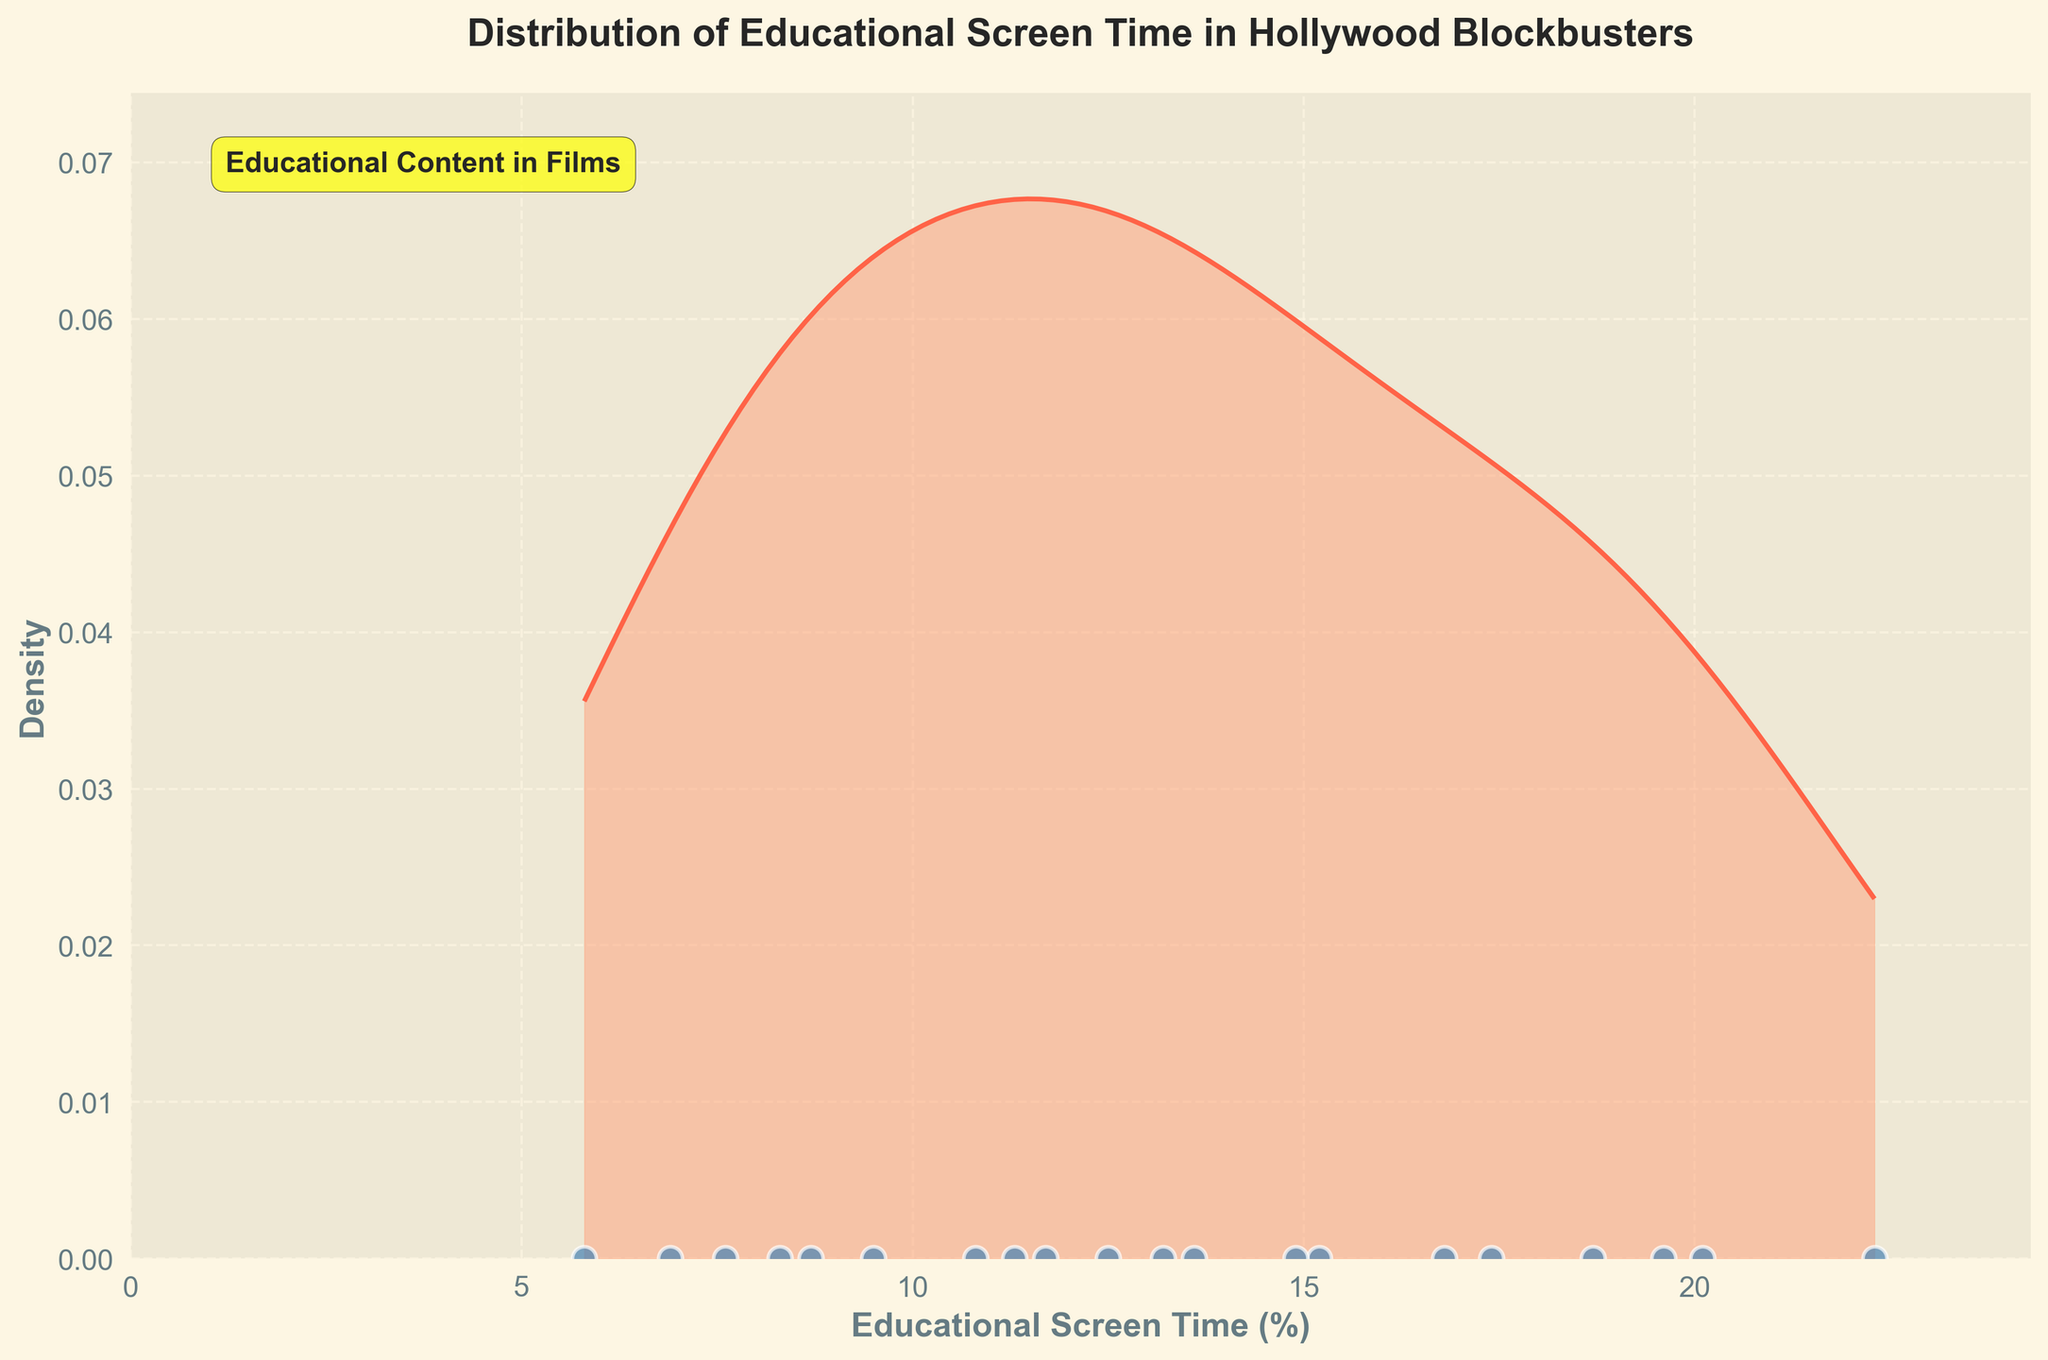What's the title of the plot? The title of the plot is typically found at the top center of the figure, indicating what the plot represents.
Answer: Distribution of Educational Screen Time in Hollywood Blockbusters What percentage of educational screen time do most movies cluster around? By analyzing the highest peak of the density plot, we can observe the general cluster of values. The peak of the distribution curve highlights the most concentrated screen time percentage.
Answer: Around 10-12% How many movies have educational screen time percentages of more than 20%? We count the individual scatter points above the 20% mark on the x-axis.
Answer: 2 movies Which movie, represented by a scatter point, has the highest educational screen time? The most rightward scatter point on the x-axis indicates the movie with the highest educational screen time.
Answer: Hidden Figures Are there more movies with educational screen times below 10% or above 10%? Count the scatter points to the left and right of the 10% mark on the x-axis. Compare the two counts to determine which side has more points.
Answer: Below 10% What is the range of educational screen times for these movies? The range is determined by subtracting the minimum value on the x-axis from the maximum value on the x-axis covered by the data points.
Answer: 5.8% to 22.3% What  percentage roughly corresponds to the median educational screen time? The median value is located by identifying the middle scatter point when the data is ordered. Since the distribution appears symmetrical, we can approximate it by observing the middle of the x-axis range covered by data points.
Answer: Around 11-12% Which movies have educational screen times closest to each of the peaks of the density curve? Identify the x-values where the density peaks and then find the movies with educational screen times closest to these peaks.
Answer: Interstellar, The Imitation Game Is the educational screen time percentage data skewed to any side? By comparing the tail lengths on each side of the peak of the density curve, we can observe if the data is skewed. If one tail is longer, the data is skewed in that direction.
Answer: Slightly skewed to the right Between 15% and 20% educational screen time, how many movies are there? Count the scatter points falling between 15% and 20% marks on the x-axis.
Answer: 5 movies 